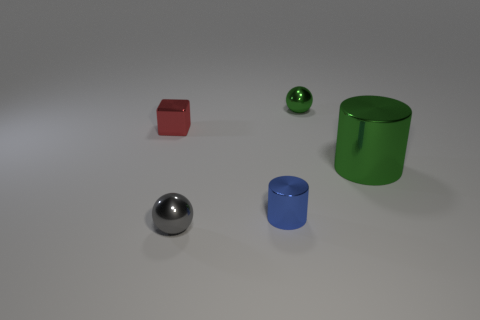Is the color of the big cylinder the same as the metallic ball in front of the large green cylinder?
Offer a terse response. No. There is a small thing that is the same color as the large cylinder; what is its shape?
Give a very brief answer. Sphere. What number of big things are blue cylinders or gray spheres?
Your answer should be compact. 0. Does the metallic block have the same color as the small metallic cylinder?
Offer a very short reply. No. Are there more things to the left of the small green metallic ball than small red metallic blocks left of the small gray thing?
Give a very brief answer. Yes. There is a tiny metallic thing that is on the left side of the gray object; is it the same color as the large thing?
Your answer should be very brief. No. Are there any other things that are the same color as the tiny metallic cube?
Your response must be concise. No. Is the number of tiny gray shiny objects right of the tiny blue metal cylinder greater than the number of large yellow metal balls?
Offer a very short reply. No. Does the gray metal sphere have the same size as the red metal block?
Your answer should be compact. Yes. What number of red things are small metal balls or cylinders?
Make the answer very short. 0. 